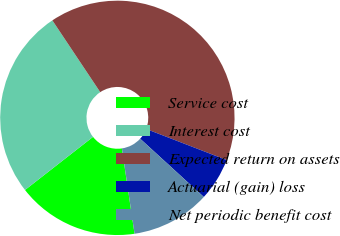<chart> <loc_0><loc_0><loc_500><loc_500><pie_chart><fcel>Service cost<fcel>Interest cost<fcel>Expected return on assets<fcel>Actuarial (gain) loss<fcel>Net periodic benefit cost<nl><fcel>16.79%<fcel>26.19%<fcel>40.22%<fcel>5.93%<fcel>10.86%<nl></chart> 